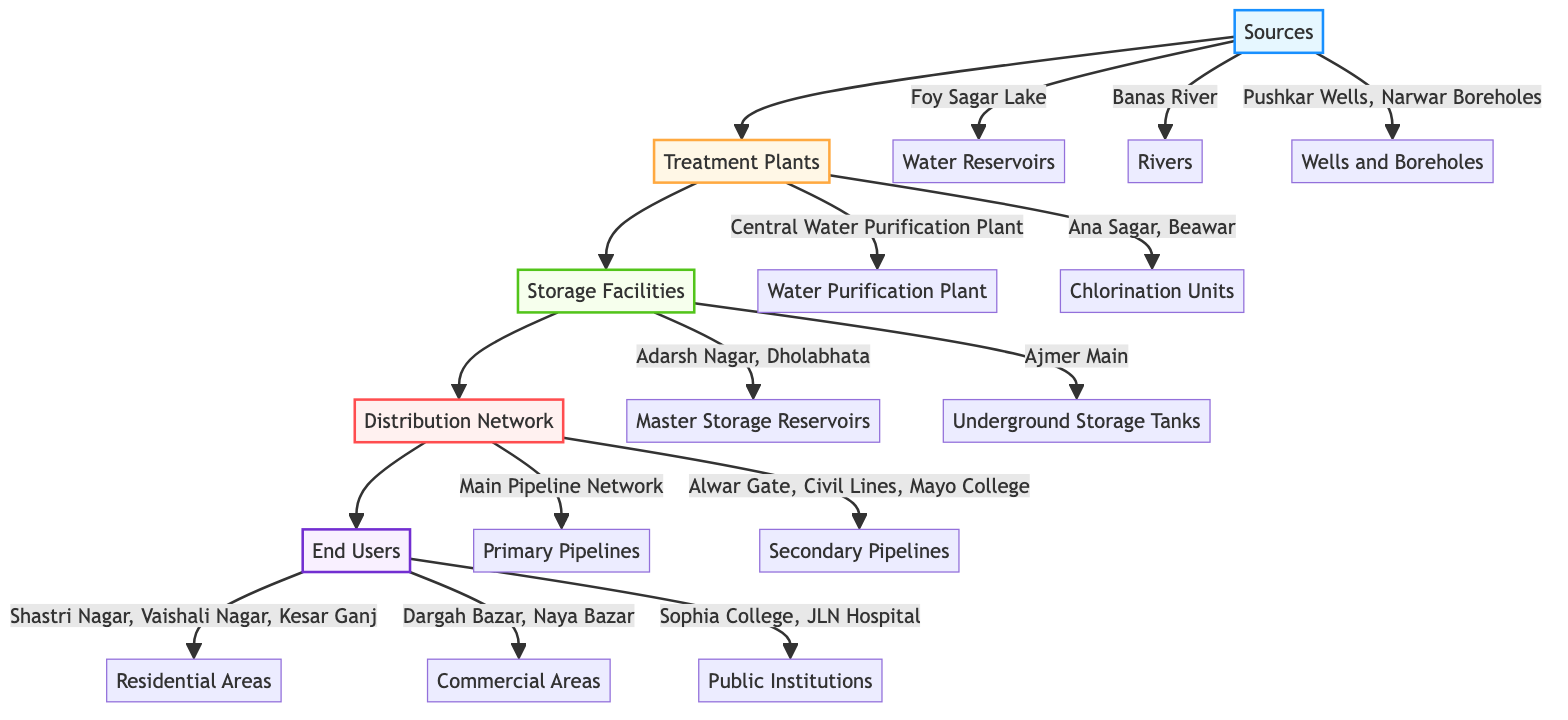What are the two main sources of water in Ajmer? The diagram identifies two main sources: Foy Sagar Lake as a water reservoir and Banas River, categorized under rivers. These are directly connected to the "Sources" node.
Answer: Foy Sagar Lake, Banas River How many chlorination units are there in the treatment plants? The diagram shows two distinct chlorination units listed under the treatment plants: Ana Sagar Chlorination Unit and Beawar Chlorination Unit, totaling to two units.
Answer: 2 What do the primary pipelines in the distribution network encompass? The distribution network lists a "Main Pipeline Network - Ajmer City" as its primary pipeline. This is a singular pathway for distributing water.
Answer: Main Pipeline Network - Ajmer City Which areas receive water service under the "Residential Areas"? The diagram indicates three residential areas serviced in Ajmer, namely Shastri Nagar, Vaishali Nagar, and Kesar Ganj. These are grouped under the "End Users" category.
Answer: Shastri Nagar, Vaishali Nagar, Kesar Ganj How many distinct storage facilities are mentioned in the diagram? In the storage facilities section, there are two types mentioned: Master Storage Reservoirs (two specific reservoirs) and one Underground Storage Tank, totaling to three distinct facilities.
Answer: 3 Which treatment plant processes the water from the sources? The diagram specifies that the Central Water Purification Plant is the treatment plant responsible for processing water, connected downstream from the "Sources" node.
Answer: Central Water Purification Plant What is the connection type between storage and distribution in the diagram? The diagram illustrates a direct flow connection from the Storage node to the Distribution node, indicating that water moves from storage facilities to the distribution network without any intermediary layers.
Answer: Direct flow connection Name one public institution listed as an end user in the diagram. The diagram mentions two public institutions under the "End Users" node, one of which is Sophia College. This institution is part of the public sector using the distributed water.
Answer: Sophia College 